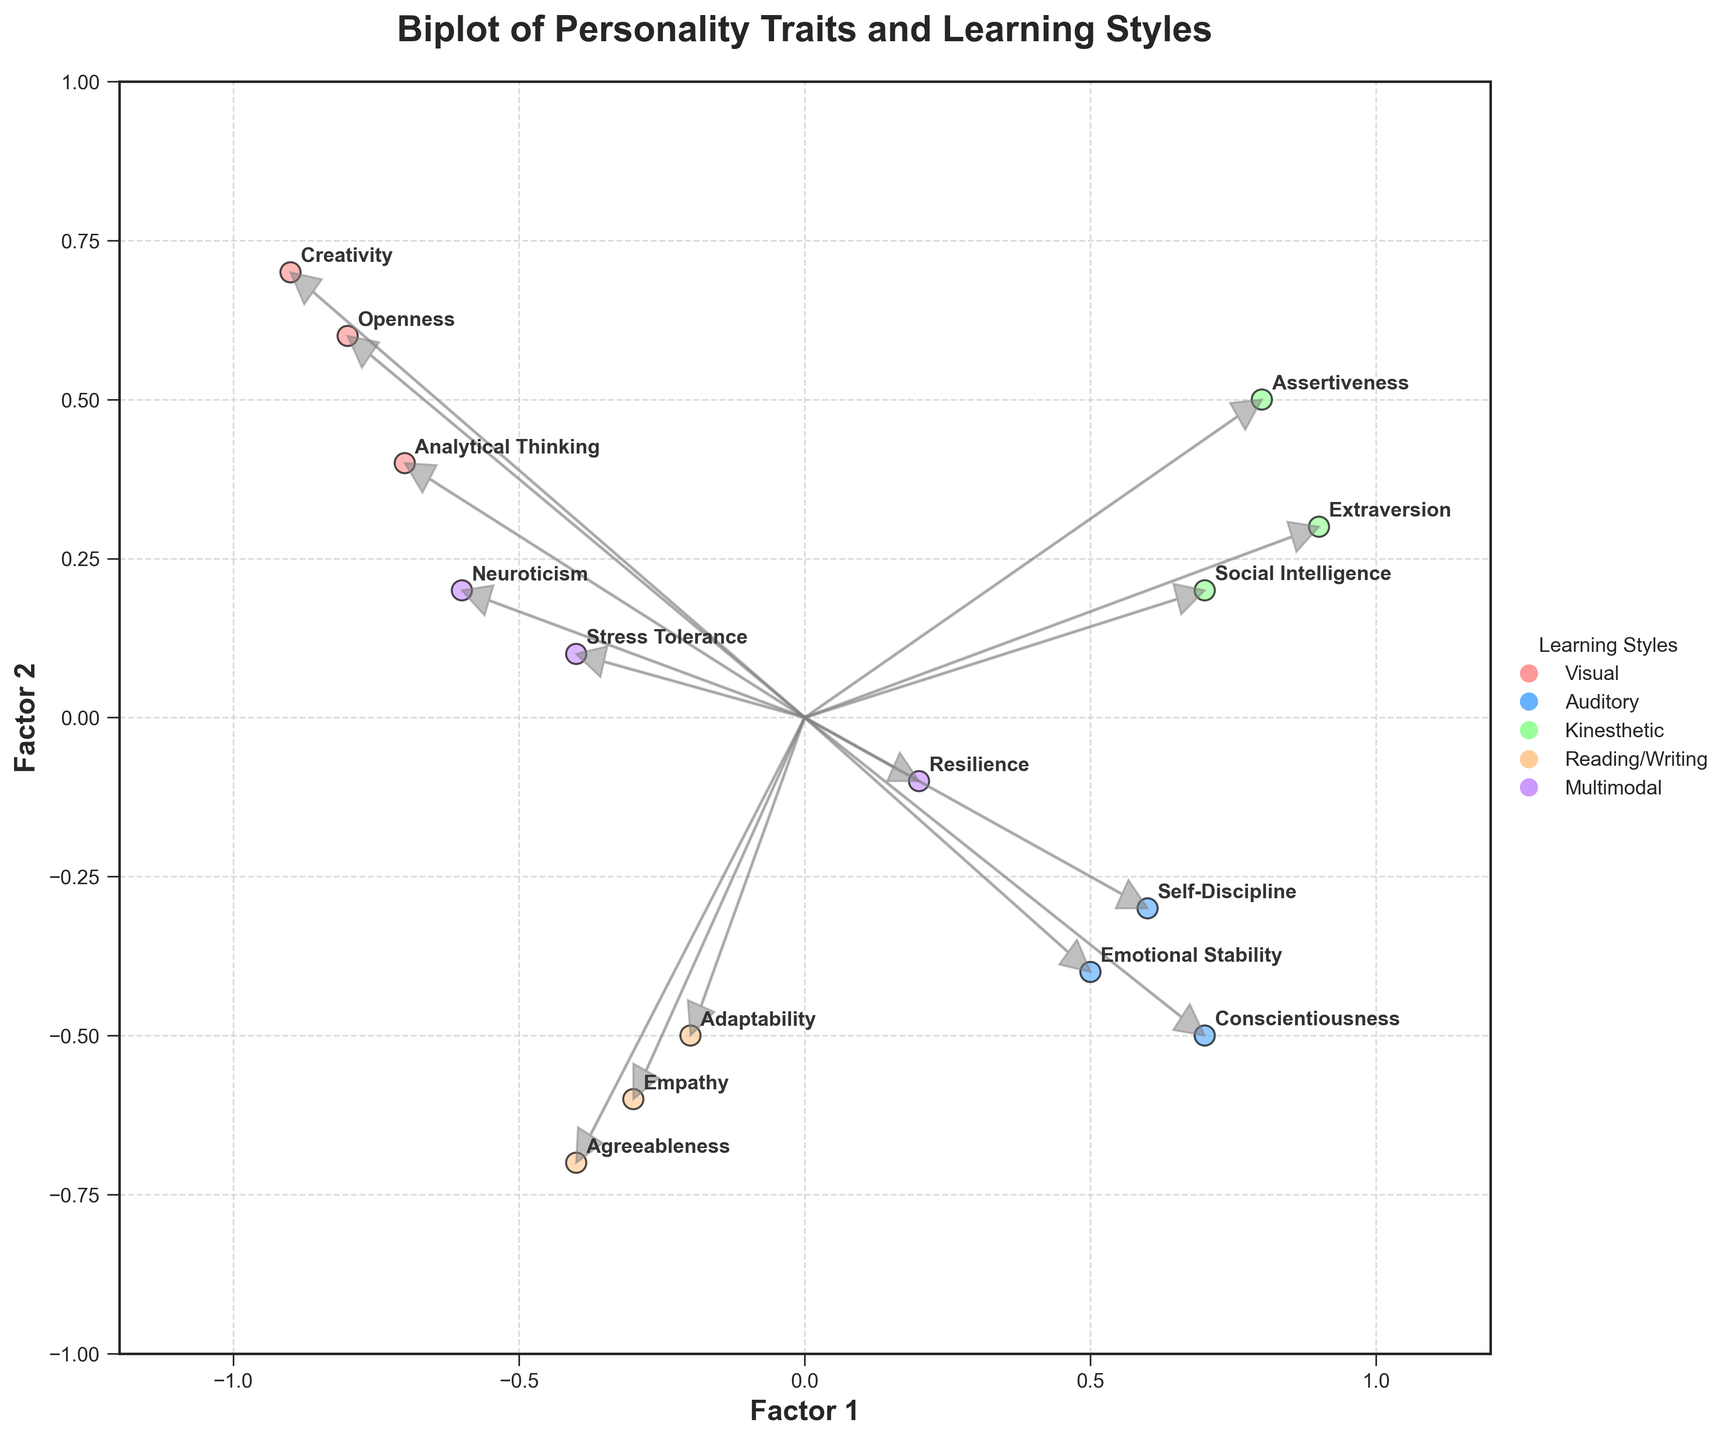What is the title of the figure? The title is written at the top of the figure in bold font. It states what the plot represents, providing a brief description of the data being visualized.
Answer: Biplot of Personality Traits and Learning Styles How many personality traits are visualized in the biplot? Count the number of different personality traits annotated in the scatter plot. Each point represents a personality trait.
Answer: 15 Which personality traits are associated with the 'Visual' learning style? Look for the points in the plot that have the same color representing the 'Visual' learning style. These points are annotated with the names of the personality traits.
Answer: Openness, Creativity, Analytical Thinking Which learning style is associated with the Factor 1 value closest to 1? Identify the point with a Factor 1 value closest to 1 on the x-axis and check the learning style indicated by the color of the point.
Answer: Kinesthetic How does 'Creativity' compare to 'Self-Discipline' in terms of Factor 2? Look at the plot to see the relative positions of the points representing 'Creativity' and 'Self-Discipline' on the y-axis (Factor 2). 'Creativity' is close to the top of the plot, while 'Self-Discipline' is below the midpoint.
Answer: Creativity is higher What's the average value of Factor 2 for personality traits associated with the 'Auditory' learning style? Find the data points corresponding to the 'Auditory' learning style and calculate their average y-values (Factor 2). These points are Conscientiousness (-0.5), Emotional Stability (-0.4), and Self-Discipline (-0.3). The average is calculated as (-0.5 + -0.4 + -0.3)/3.
Answer: -0.4 Which two personality traits have the smallest angle between their arrow vectors? Observe the plot to find arrow vectors that are closely aligned. Calculate or visually assess the angles between them.
Answer: Assertiveness and Extraversion Is 'Resilience' more aligned with Factor 1 or Factor 2? Check the plot to see whether the point representing 'Resilience' is closer to the x-axis or y-axis.
Answer: More aligned with Factor 1 Which personality trait has the lowest value on Factor 1? Find the point that is farthest to the left on the x-axis, which corresponds to the lower values of Factor 1.
Answer: Creativity Do more personality traits fall into the positive or negative region of Factor 2? Count the number of data points above and below the y=0 line. Compare these counts to determine the region with more traits.
Answer: Negative region 